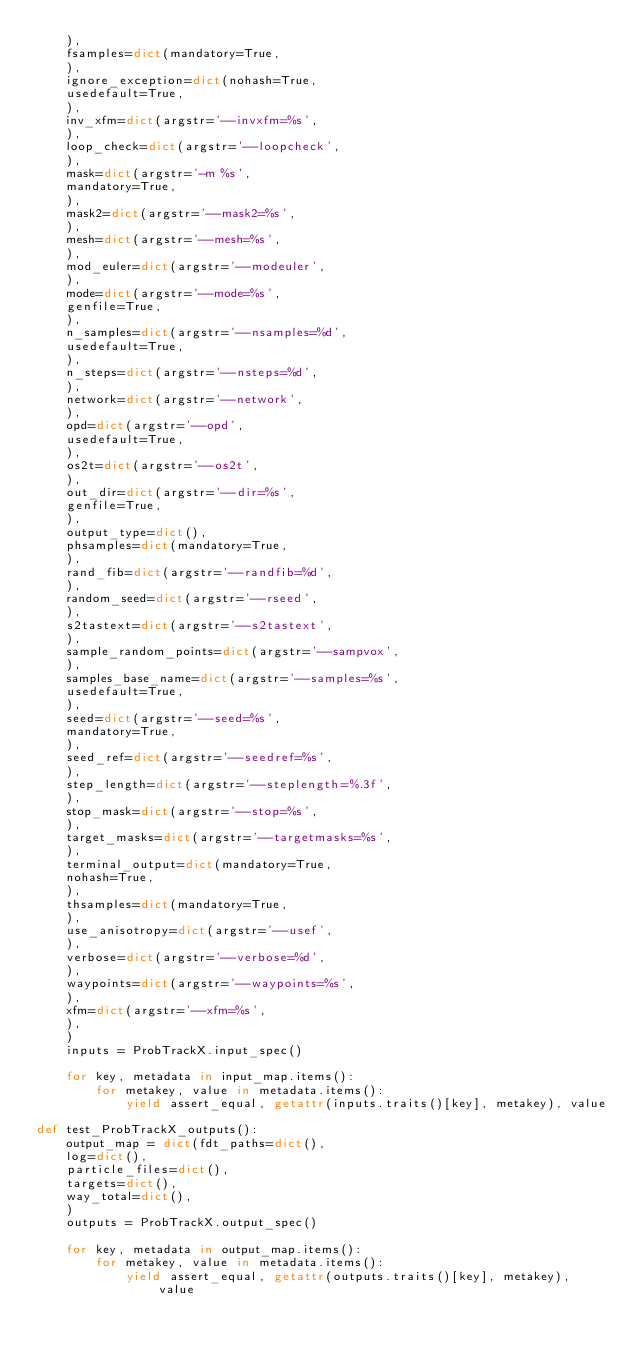<code> <loc_0><loc_0><loc_500><loc_500><_Python_>    ),
    fsamples=dict(mandatory=True,
    ),
    ignore_exception=dict(nohash=True,
    usedefault=True,
    ),
    inv_xfm=dict(argstr='--invxfm=%s',
    ),
    loop_check=dict(argstr='--loopcheck',
    ),
    mask=dict(argstr='-m %s',
    mandatory=True,
    ),
    mask2=dict(argstr='--mask2=%s',
    ),
    mesh=dict(argstr='--mesh=%s',
    ),
    mod_euler=dict(argstr='--modeuler',
    ),
    mode=dict(argstr='--mode=%s',
    genfile=True,
    ),
    n_samples=dict(argstr='--nsamples=%d',
    usedefault=True,
    ),
    n_steps=dict(argstr='--nsteps=%d',
    ),
    network=dict(argstr='--network',
    ),
    opd=dict(argstr='--opd',
    usedefault=True,
    ),
    os2t=dict(argstr='--os2t',
    ),
    out_dir=dict(argstr='--dir=%s',
    genfile=True,
    ),
    output_type=dict(),
    phsamples=dict(mandatory=True,
    ),
    rand_fib=dict(argstr='--randfib=%d',
    ),
    random_seed=dict(argstr='--rseed',
    ),
    s2tastext=dict(argstr='--s2tastext',
    ),
    sample_random_points=dict(argstr='--sampvox',
    ),
    samples_base_name=dict(argstr='--samples=%s',
    usedefault=True,
    ),
    seed=dict(argstr='--seed=%s',
    mandatory=True,
    ),
    seed_ref=dict(argstr='--seedref=%s',
    ),
    step_length=dict(argstr='--steplength=%.3f',
    ),
    stop_mask=dict(argstr='--stop=%s',
    ),
    target_masks=dict(argstr='--targetmasks=%s',
    ),
    terminal_output=dict(mandatory=True,
    nohash=True,
    ),
    thsamples=dict(mandatory=True,
    ),
    use_anisotropy=dict(argstr='--usef',
    ),
    verbose=dict(argstr='--verbose=%d',
    ),
    waypoints=dict(argstr='--waypoints=%s',
    ),
    xfm=dict(argstr='--xfm=%s',
    ),
    )
    inputs = ProbTrackX.input_spec()

    for key, metadata in input_map.items():
        for metakey, value in metadata.items():
            yield assert_equal, getattr(inputs.traits()[key], metakey), value

def test_ProbTrackX_outputs():
    output_map = dict(fdt_paths=dict(),
    log=dict(),
    particle_files=dict(),
    targets=dict(),
    way_total=dict(),
    )
    outputs = ProbTrackX.output_spec()

    for key, metadata in output_map.items():
        for metakey, value in metadata.items():
            yield assert_equal, getattr(outputs.traits()[key], metakey), value

</code> 